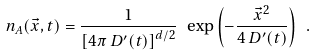Convert formula to latex. <formula><loc_0><loc_0><loc_500><loc_500>n _ { A } ( { \vec { x } } , t ) = \frac { 1 } { \left [ 4 \pi \, D ^ { \prime } ( t ) \right ] ^ { d / 2 } } \ \exp \left ( - \frac { { \vec { x } } ^ { 2 } } { 4 \, D ^ { \prime } ( t ) } \right ) \ .</formula> 